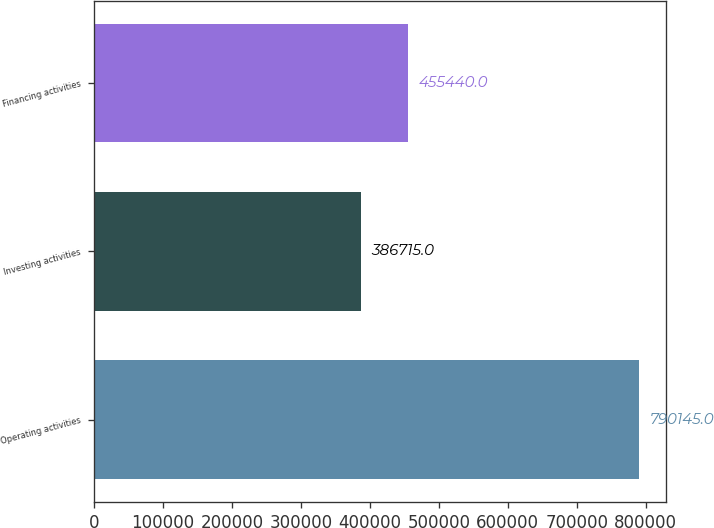Convert chart. <chart><loc_0><loc_0><loc_500><loc_500><bar_chart><fcel>Operating activities<fcel>Investing activities<fcel>Financing activities<nl><fcel>790145<fcel>386715<fcel>455440<nl></chart> 